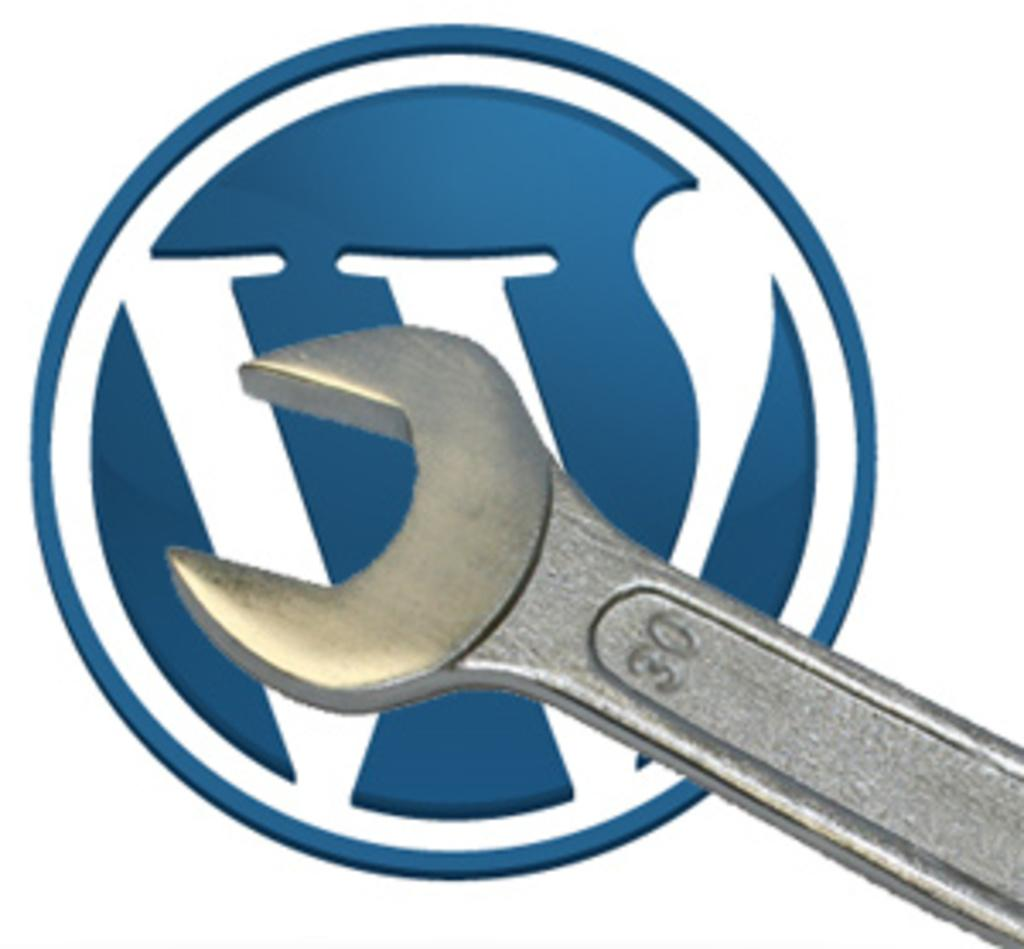What tool is present in the image? There is a spanner or a wrench in the image. What color is the logo in the image? The logo in the image is blue. What color is the background of the image? The background of the image is white. How does the iron help the representative sleep better in the image? There is no iron or representative present in the image, and therefore no such interaction can be observed. 